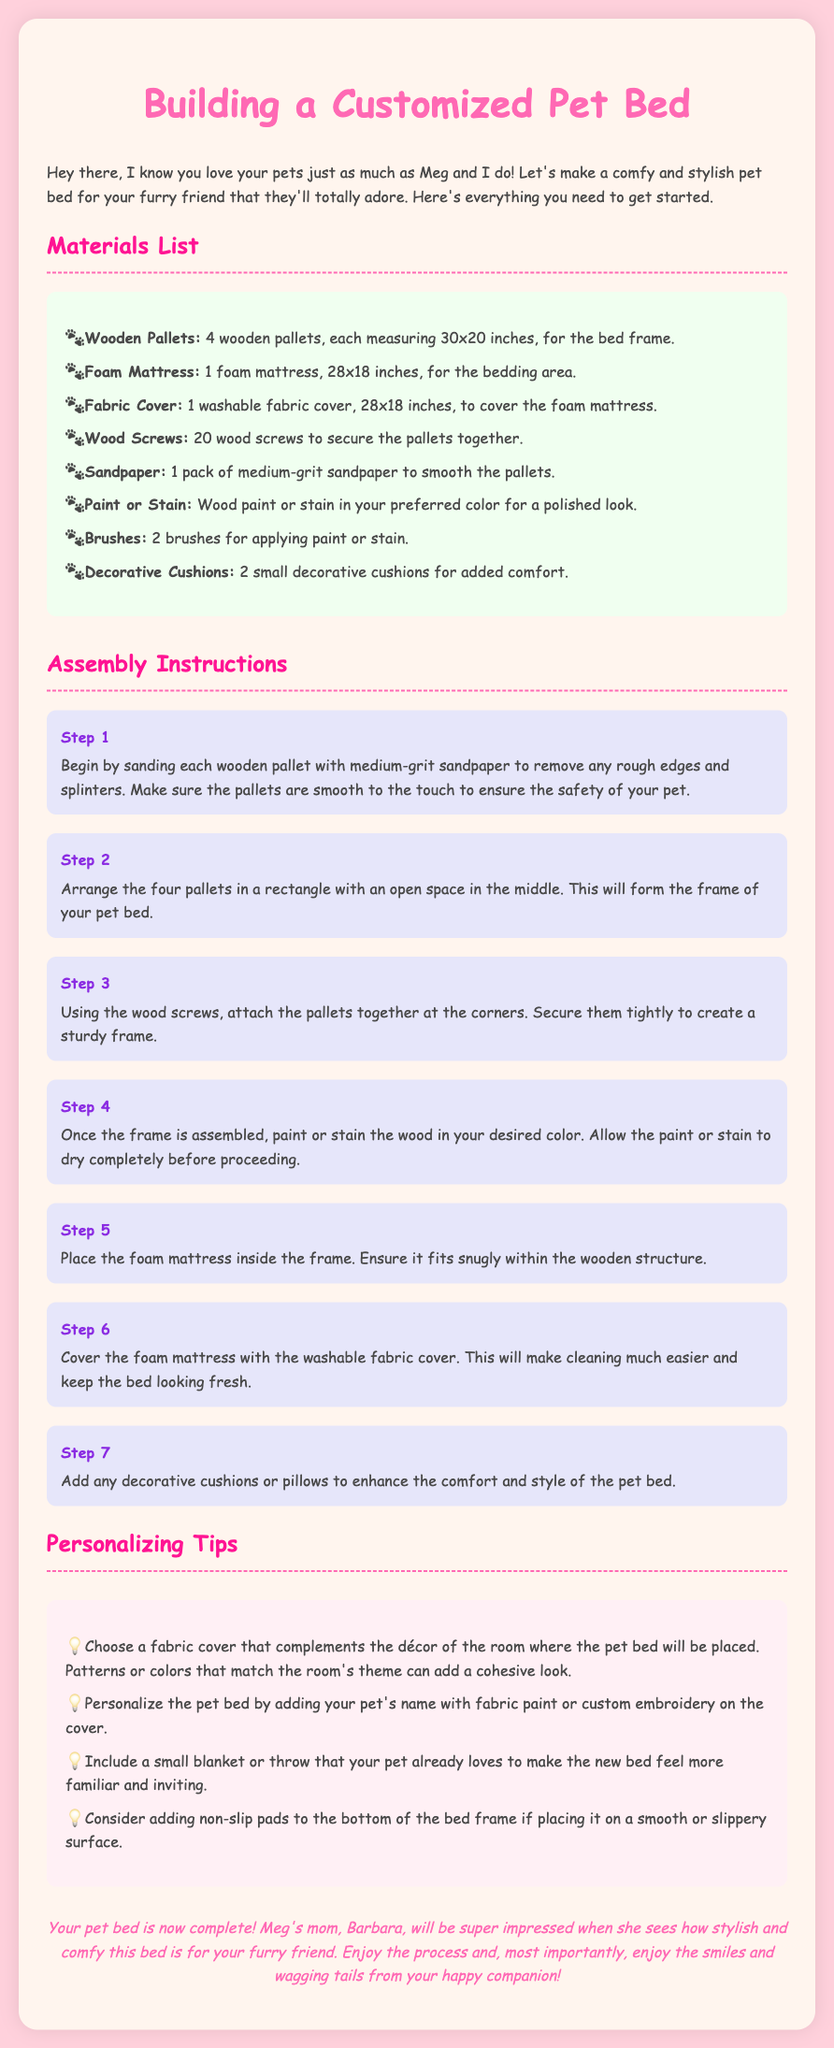What are the dimensions of the foam mattress? The document states that the foam mattress measures 28x18 inches.
Answer: 28x18 inches How many wood screws are needed? According to the materials list, 20 wood screws are required.
Answer: 20 What color should the text in the document's header be? The header color is specified as #FF69B4.
Answer: #FF69B4 What is the first step in the assembly instructions? The first step is to sand each wooden pallet with medium-grit sandpaper.
Answer: Sand pallets What is one way to personalize the pet bed? One suggestion is to add your pet's name with fabric paint or custom embroidery on the cover.
Answer: Add pet's name How many decorative cushions are recommended for comfort? The materials list suggests using 2 small decorative cushions.
Answer: 2 Why is it recommended to let the paint or stain dry completely? This ensures that the finish does not interfere with the mattress placement and overall safety.
Answer: Safety What should be used to cover the foam mattress? A washable fabric cover is recommended for the foam mattress.
Answer: Washable fabric cover What is the purpose of adding non-slip pads? Non-slip pads provide increased stability if the pet bed is placed on a smooth surface.
Answer: Stability 